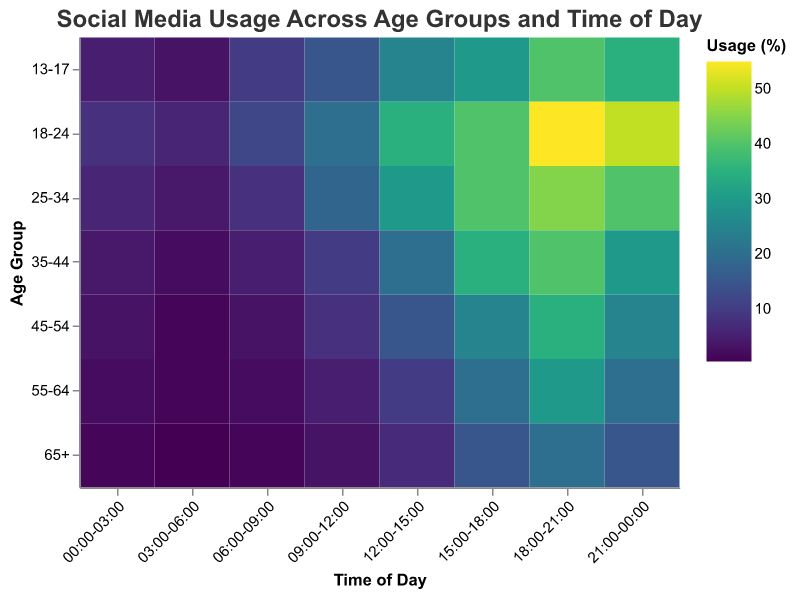What is the title of the heatmap? The title of the heatmap is displayed at the top and usually provides a summary of what the heatmap is about. Here, it is clearly written.
Answer: Social Media Usage Across Age Groups and Time of Day Which age group has the highest social media usage in the 18:00-21:00 time slot? To find the age group with the highest usage in the 18:00-21:00 time slot, locate the column for 18:00-21:00 and find the highest value within that column.
Answer: 18-24 What is the social media usage percentage for the 35-44 age group at 03:00-06:00? Locate the row corresponding to the 35-44 age group and then find the intersection with the column for 03:00-06:00.
Answer: 2 Which time period shows the most social media usage for the 25-34 age group? Look across the row for the 25-34 age group and identify the highest value. This value's corresponding column gives the time period.
Answer: 18:00-21:00 How does the social media usage for the 13-17 age group change throughout the day? Observe the trend of values across the row corresponding to the 13-17 age group from 00:00-03:00 to 21:00-00:00.
Answer: It increases from 5 to 40 and then slightly decreases to 35 What is the difference in social media usage between the 18-24 and 55-64 age groups during the 12:00-15:00 time period? Find the values for 18-24 and 55-64 in the 12:00-15:00 column and subtract the smaller value from the larger value.
Answer: 25 At what time period is the social media usage the lowest for the 65+ age group? Look across the row corresponding to the 65+ age group and find the smallest value. The corresponding column is the time period.
Answer: 03:00-06:00 Which age group shows more consistent social media usage throughout the day? Compare the values across the rows for each age group. Consistency can be inferred from the small variation in values throughout the day.
Answer: 65+ What is the average social media usage percentage for the 45-54 age group throughout the day? Sum up the values for the 45-54 age group and divide by the number of time periods to find the average.
Answer: 14.375 Which two adjacent time slots have the most significant increase in social media usage for the age group 18-24? Calculate the difference in values between consecutive time slots for the 18-24 age group and identify the pair with the highest difference.
Answer: 15:00-18:00 to 18:00-21:00 